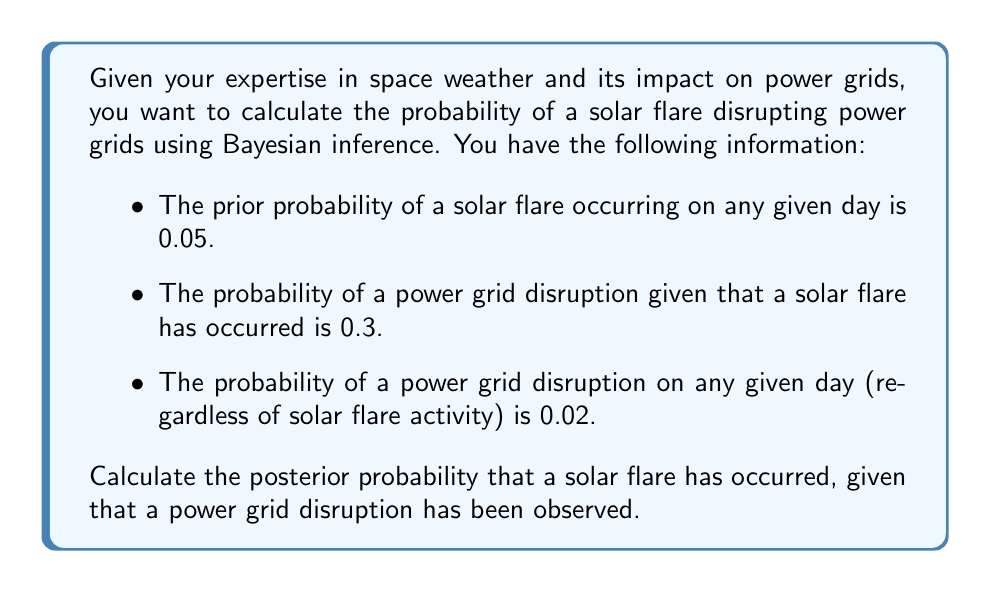What is the answer to this math problem? To solve this problem, we'll use Bayes' theorem, which is fundamental in Bayesian inference. The theorem is expressed as:

$$P(A|B) = \frac{P(B|A) \cdot P(A)}{P(B)}$$

Where:
- $A$ is the event of a solar flare occurring
- $B$ is the event of a power grid disruption

Given:
- $P(A) = 0.05$ (prior probability of a solar flare)
- $P(B|A) = 0.3$ (probability of grid disruption given a solar flare)
- $P(B) = 0.02$ (total probability of grid disruption)

We want to find $P(A|B)$, the probability of a solar flare given a grid disruption.

Step 1: Apply Bayes' theorem
$$P(A|B) = \frac{P(B|A) \cdot P(A)}{P(B)}$$

Step 2: Substitute the known values
$$P(A|B) = \frac{0.3 \cdot 0.05}{0.02}$$

Step 3: Calculate the result
$$P(A|B) = \frac{0.015}{0.02} = 0.75$$

Therefore, the posterior probability that a solar flare has occurred, given that a power grid disruption has been observed, is 0.75 or 75%.
Answer: 0.75 or 75% 